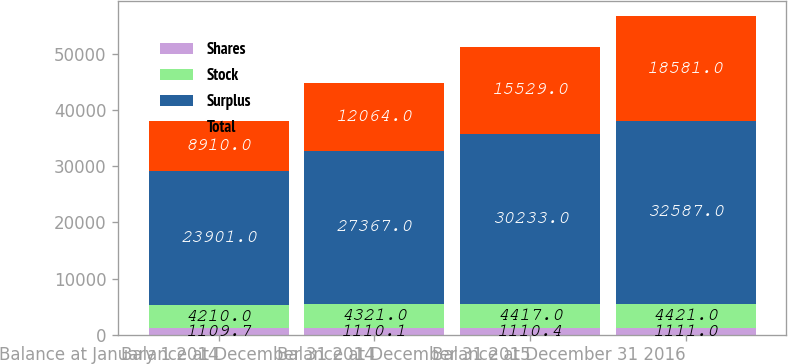<chart> <loc_0><loc_0><loc_500><loc_500><stacked_bar_chart><ecel><fcel>Balance at January 1 2014<fcel>Balance at December 31 2014<fcel>Balance at December 31 2015<fcel>Balance at December 31 2016<nl><fcel>Shares<fcel>1109.7<fcel>1110.1<fcel>1110.4<fcel>1111<nl><fcel>Stock<fcel>4210<fcel>4321<fcel>4417<fcel>4421<nl><fcel>Surplus<fcel>23901<fcel>27367<fcel>30233<fcel>32587<nl><fcel>Total<fcel>8910<fcel>12064<fcel>15529<fcel>18581<nl></chart> 